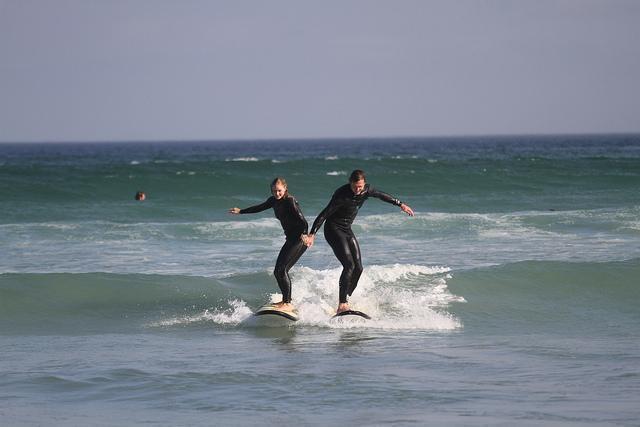How do these people know each other?
Choose the correct response, then elucidate: 'Answer: answer
Rationale: rationale.'
Options: Coworkers, spouses, rivals, pen pals. Answer: spouses.
Rationale: They are holding hands like they have a close relationship. 